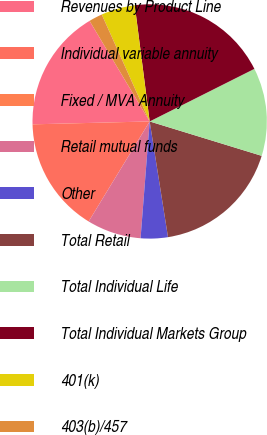Convert chart. <chart><loc_0><loc_0><loc_500><loc_500><pie_chart><fcel>Revenues by Product Line<fcel>Individual variable annuity<fcel>Fixed / MVA Annuity<fcel>Retail mutual funds<fcel>Other<fcel>Total Retail<fcel>Total Individual Life<fcel>Total Individual Markets Group<fcel>401(k)<fcel>403(b)/457<nl><fcel>16.82%<fcel>15.89%<fcel>0.0%<fcel>7.48%<fcel>3.74%<fcel>17.76%<fcel>12.15%<fcel>19.63%<fcel>4.67%<fcel>1.87%<nl></chart> 